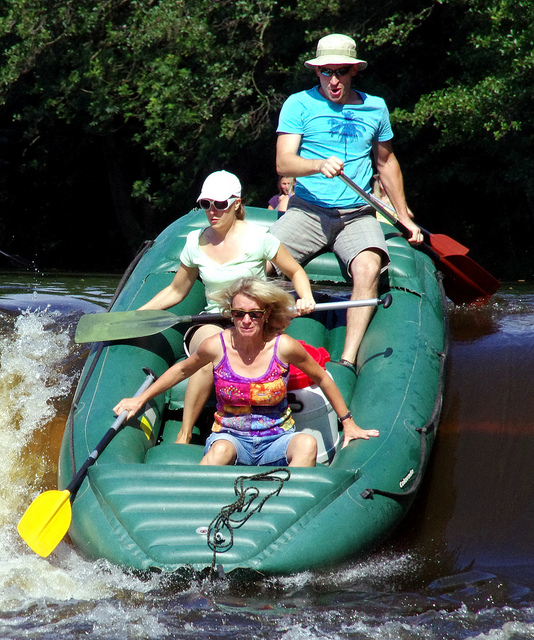How would you describe the environment where this rafting activity is taking place? The rafting activity is taking place in a dynamic river setting, likely in a natural, forested area. The water appears to be moving swiftly, indicating that it might be a section of whitewater rapids, which is a challenging and thrilling environment for rafting enthusiasts. 